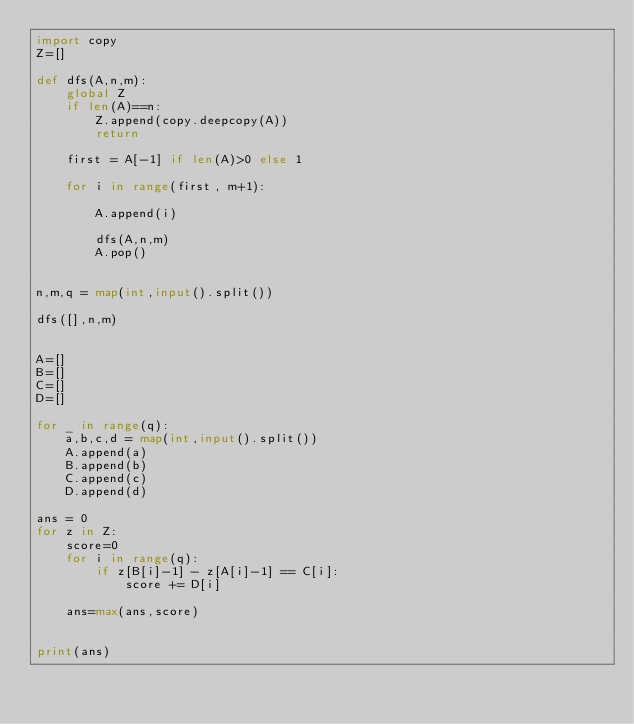<code> <loc_0><loc_0><loc_500><loc_500><_Python_>import copy
Z=[]

def dfs(A,n,m):
    global Z
    if len(A)==n:
        Z.append(copy.deepcopy(A))
        return
    
    first = A[-1] if len(A)>0 else 1
    
    for i in range(first, m+1):
        
        A.append(i)
        
        dfs(A,n,m)
        A.pop()
    

n,m,q = map(int,input().split()) 

dfs([],n,m)


A=[]
B=[]
C=[]
D=[]

for _ in range(q):
    a,b,c,d = map(int,input().split()) 
    A.append(a)
    B.append(b)
    C.append(c)
    D.append(d)
    
ans = 0    
for z in Z:
    score=0
    for i in range(q):
        if z[B[i]-1] - z[A[i]-1] == C[i]:
            score += D[i]
            
    ans=max(ans,score)
        
    
print(ans)
</code> 